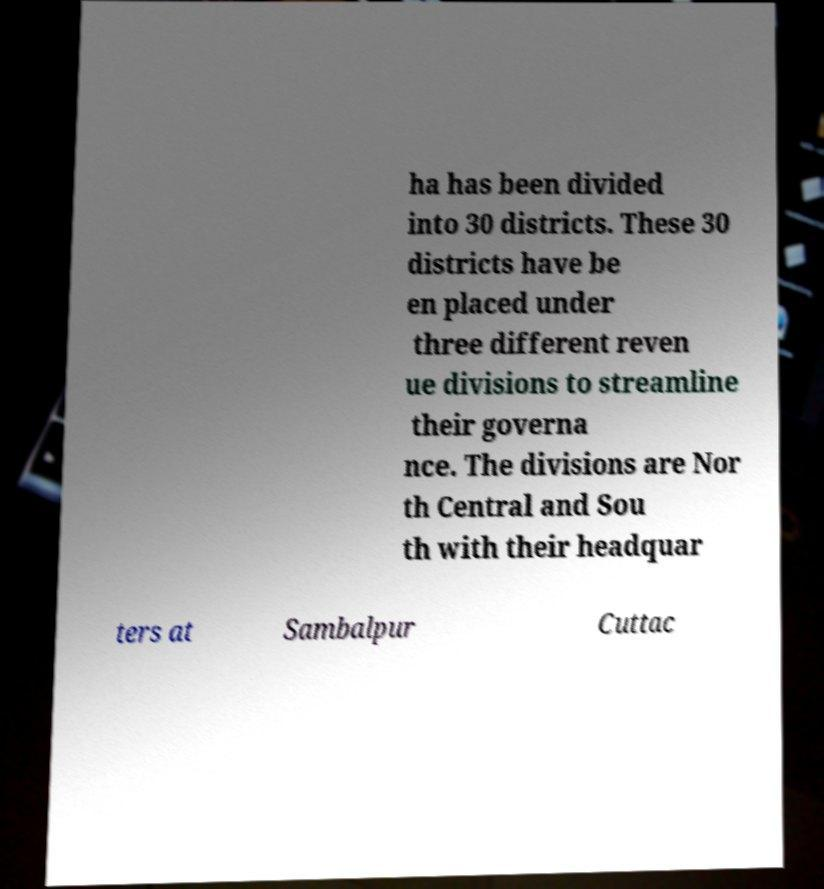For documentation purposes, I need the text within this image transcribed. Could you provide that? ha has been divided into 30 districts. These 30 districts have be en placed under three different reven ue divisions to streamline their governa nce. The divisions are Nor th Central and Sou th with their headquar ters at Sambalpur Cuttac 